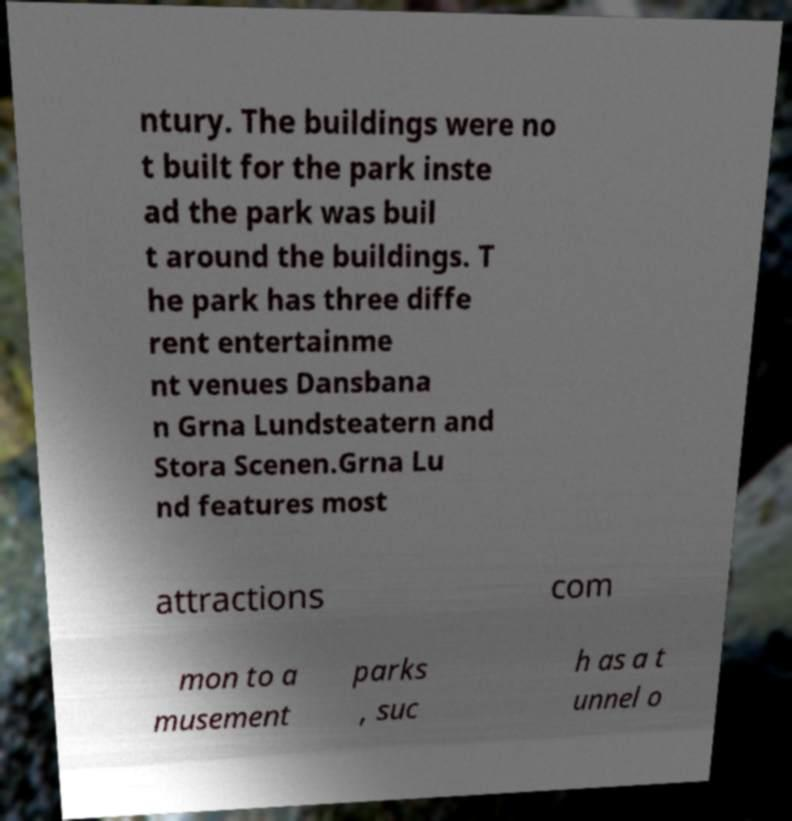Could you assist in decoding the text presented in this image and type it out clearly? ntury. The buildings were no t built for the park inste ad the park was buil t around the buildings. T he park has three diffe rent entertainme nt venues Dansbana n Grna Lundsteatern and Stora Scenen.Grna Lu nd features most attractions com mon to a musement parks , suc h as a t unnel o 